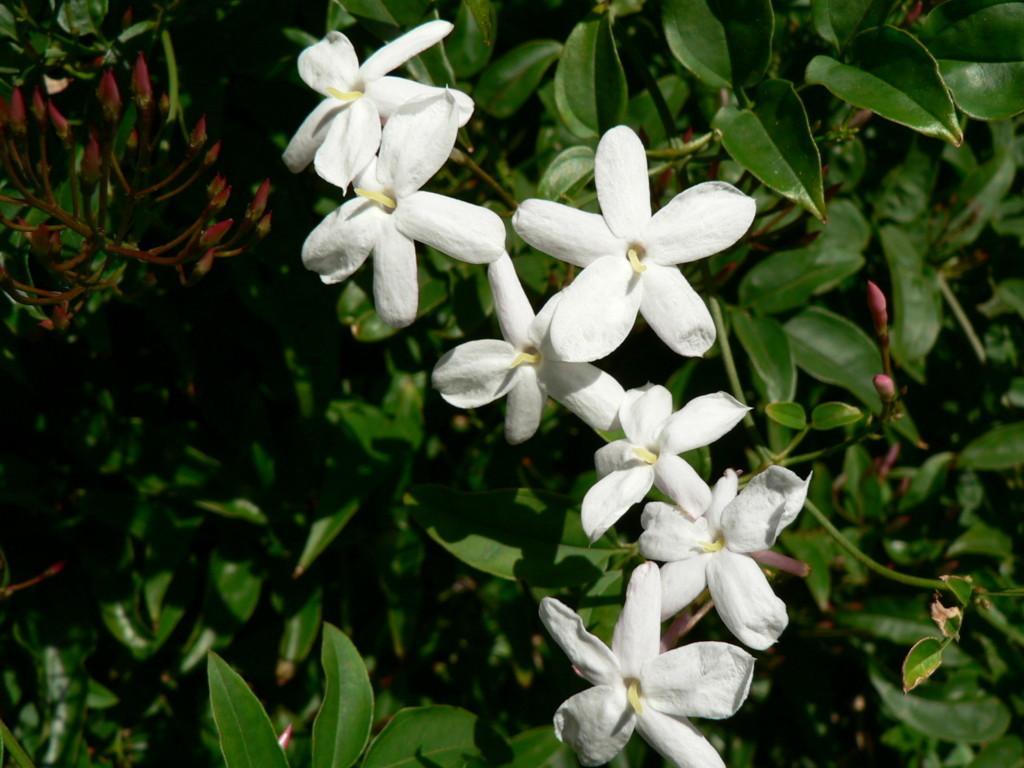How would you summarize this image in a sentence or two? In the picture I can see flower plants. These flowers are white in color. 